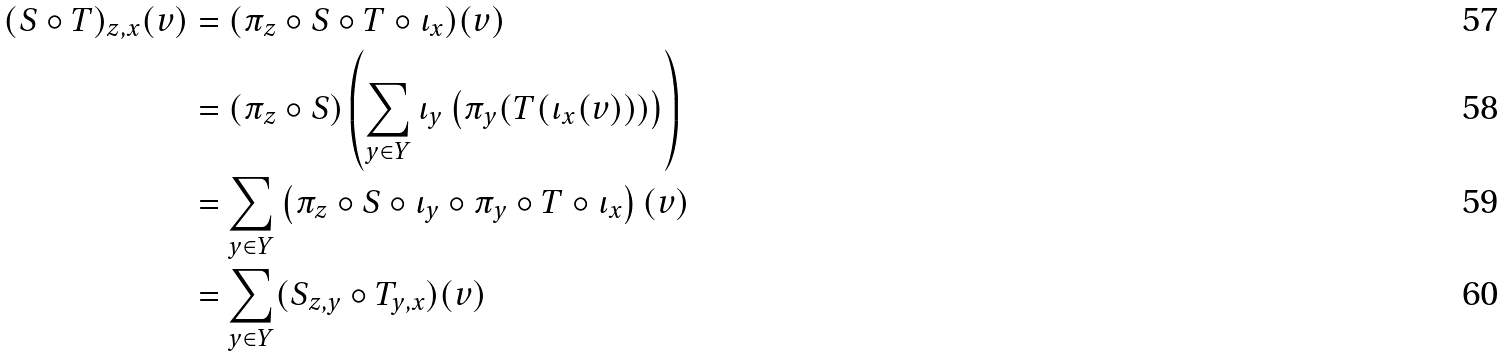Convert formula to latex. <formula><loc_0><loc_0><loc_500><loc_500>( S \circ T ) _ { z , x } ( v ) & = ( \pi _ { z } \circ S \circ T \circ \iota _ { x } ) ( v ) \\ & = \left ( \pi _ { z } \circ S \right ) \left ( \sum _ { y \in Y } \iota _ { y } \left ( \pi _ { y } ( T ( \iota _ { x } ( v ) ) ) \right ) \right ) \\ & = \sum _ { y \in Y } \left ( \pi _ { z } \circ S \circ \iota _ { y } \circ \pi _ { y } \circ T \circ \iota _ { x } \right ) ( v ) \\ & = \sum _ { y \in Y } ( S _ { z , y } \circ T _ { y , x } ) ( v )</formula> 